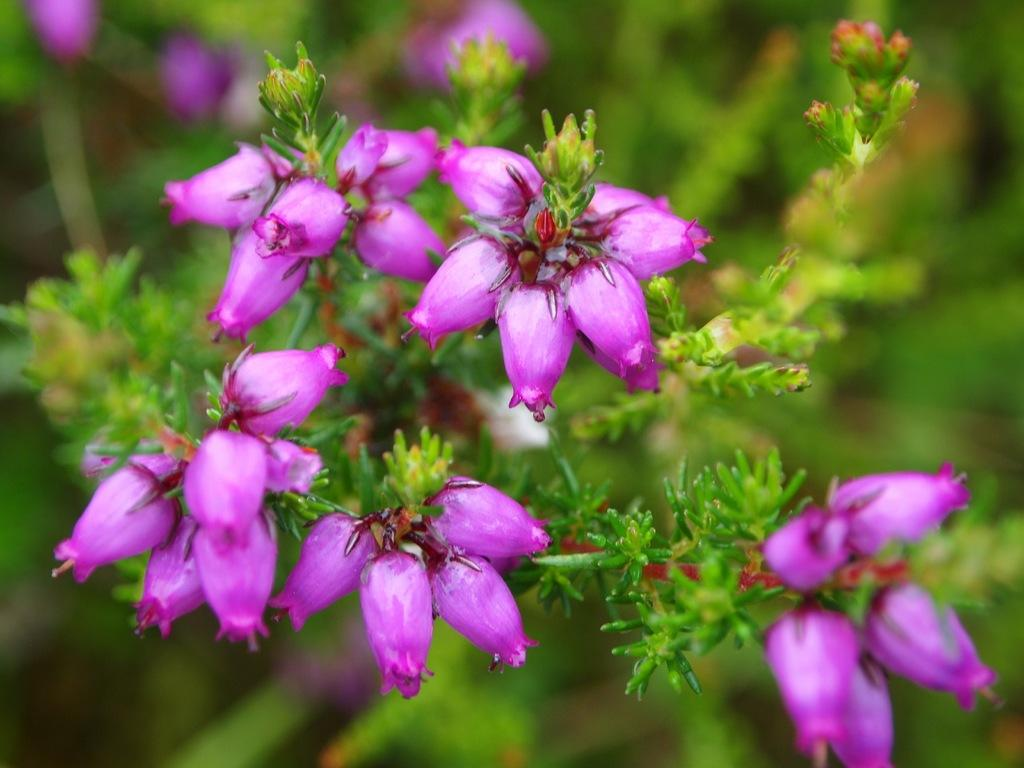What is present in the image? There is a plant in the image. Can you describe the flowers on the plant? The plant has violet color flowers. What can be observed about the background of the image? The background of the image is blurred. What type of square example can be seen in the image? There is no square or example present in the image; it features a plant with violet flowers against a blurred background. 